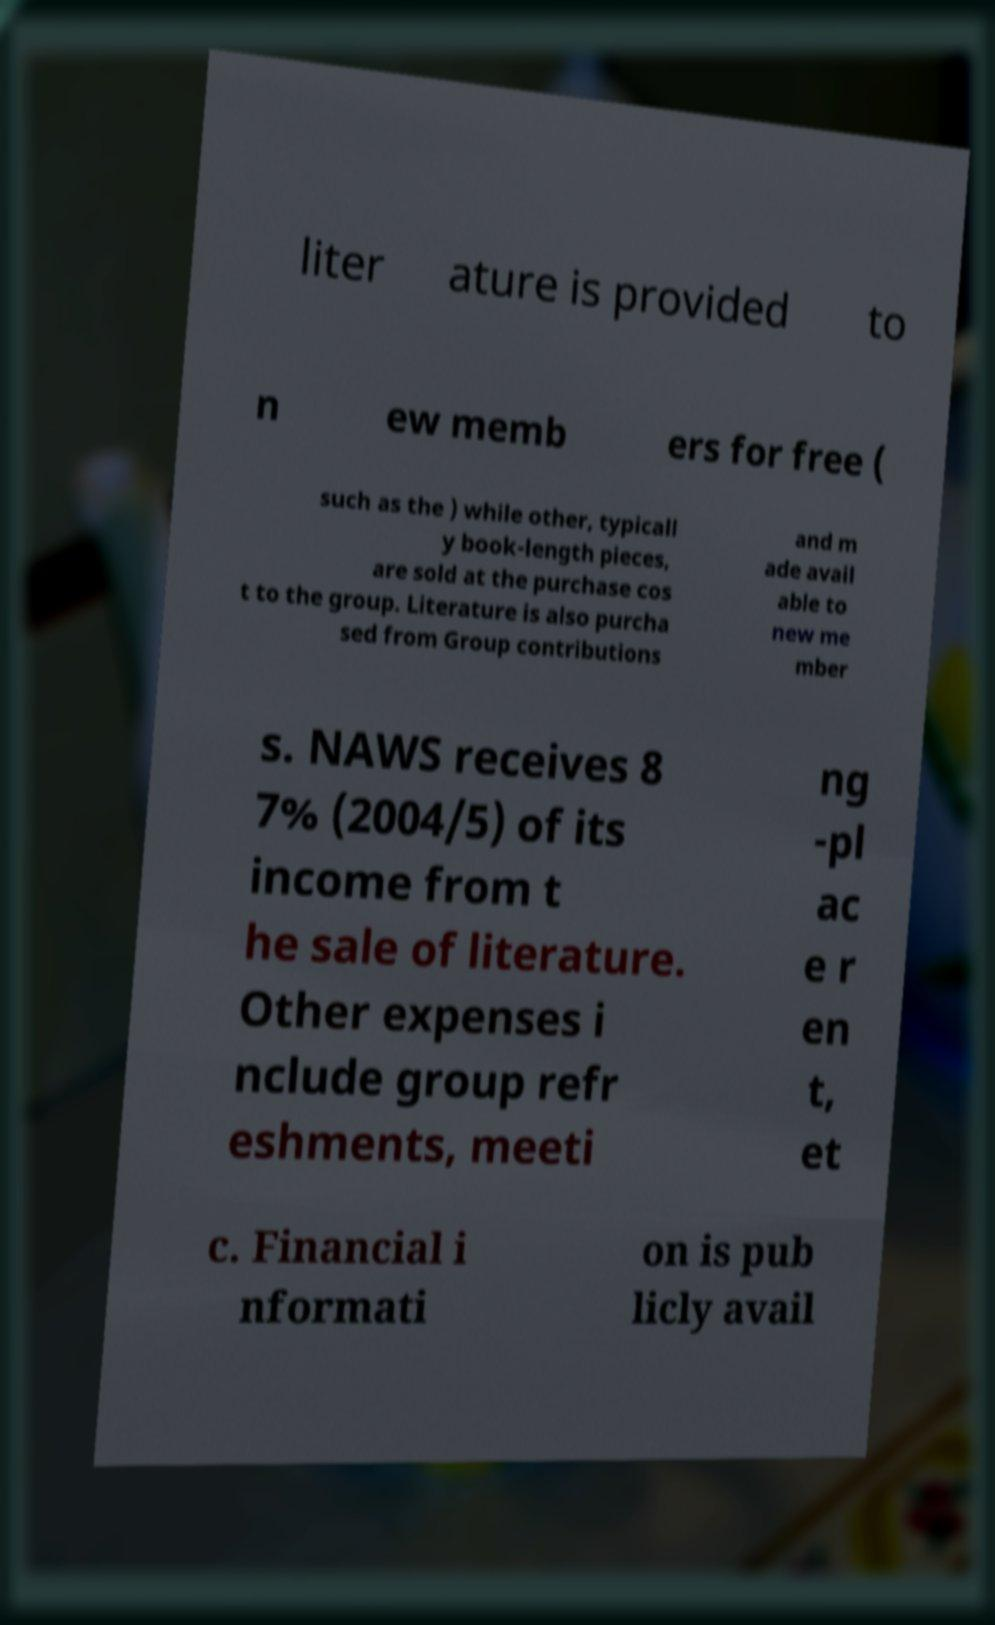I need the written content from this picture converted into text. Can you do that? liter ature is provided to n ew memb ers for free ( such as the ) while other, typicall y book-length pieces, are sold at the purchase cos t to the group. Literature is also purcha sed from Group contributions and m ade avail able to new me mber s. NAWS receives 8 7% (2004/5) of its income from t he sale of literature. Other expenses i nclude group refr eshments, meeti ng -pl ac e r en t, et c. Financial i nformati on is pub licly avail 